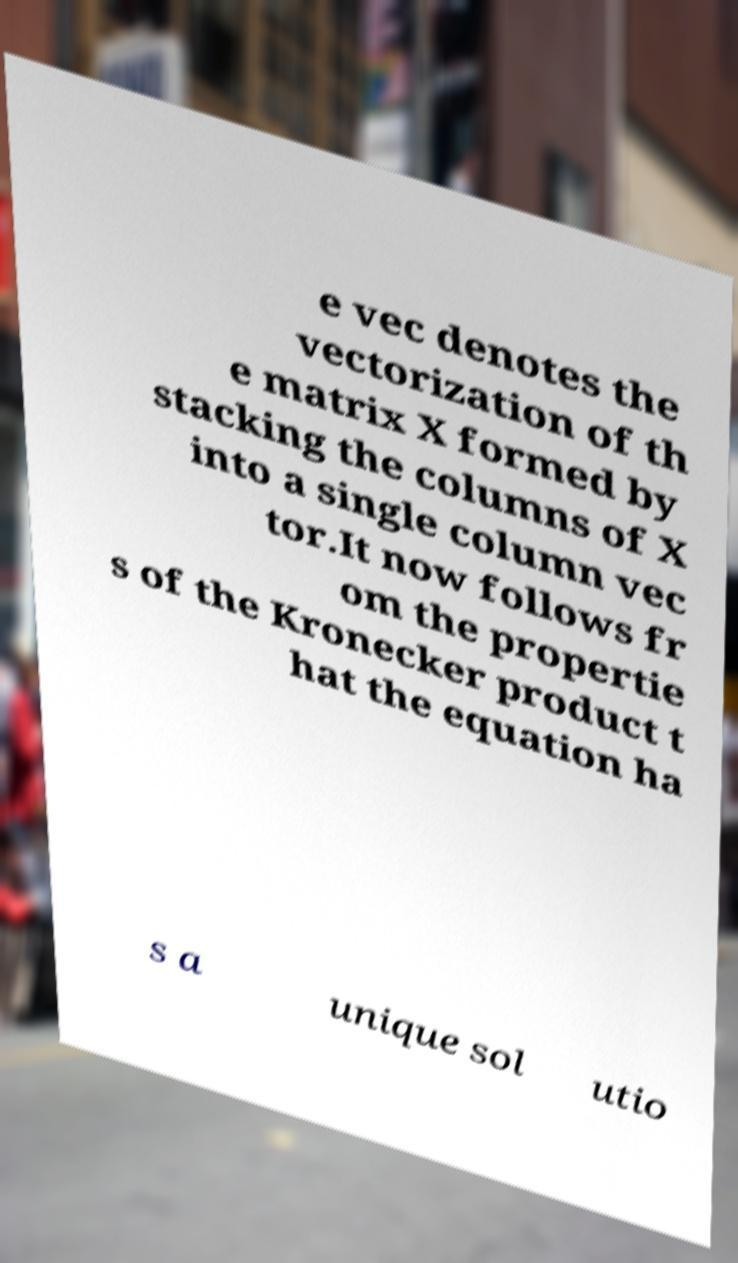There's text embedded in this image that I need extracted. Can you transcribe it verbatim? e vec denotes the vectorization of th e matrix X formed by stacking the columns of X into a single column vec tor.It now follows fr om the propertie s of the Kronecker product t hat the equation ha s a unique sol utio 